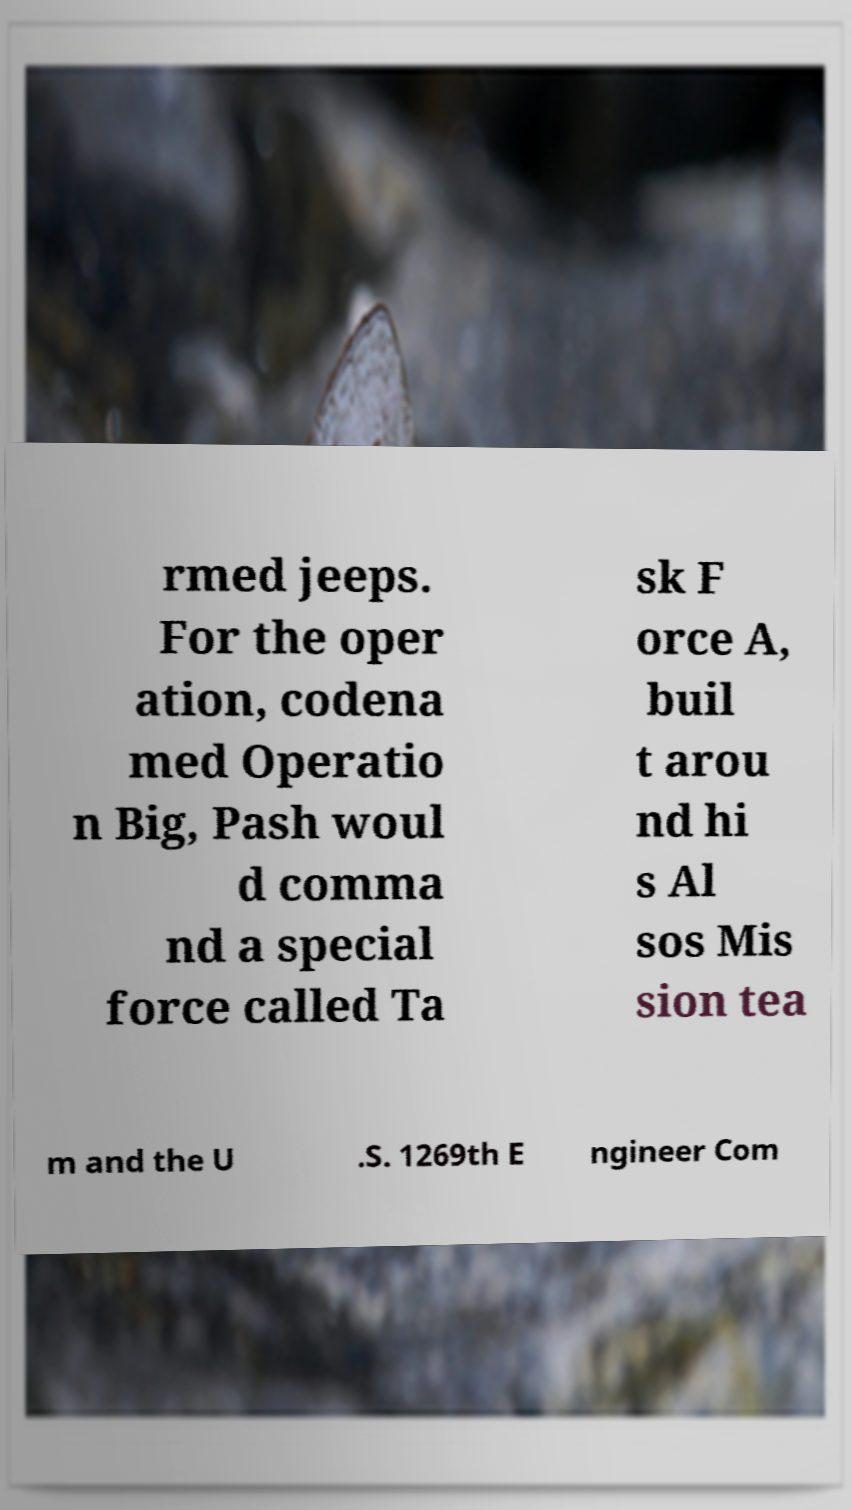Could you assist in decoding the text presented in this image and type it out clearly? rmed jeeps. For the oper ation, codena med Operatio n Big, Pash woul d comma nd a special force called Ta sk F orce A, buil t arou nd hi s Al sos Mis sion tea m and the U .S. 1269th E ngineer Com 